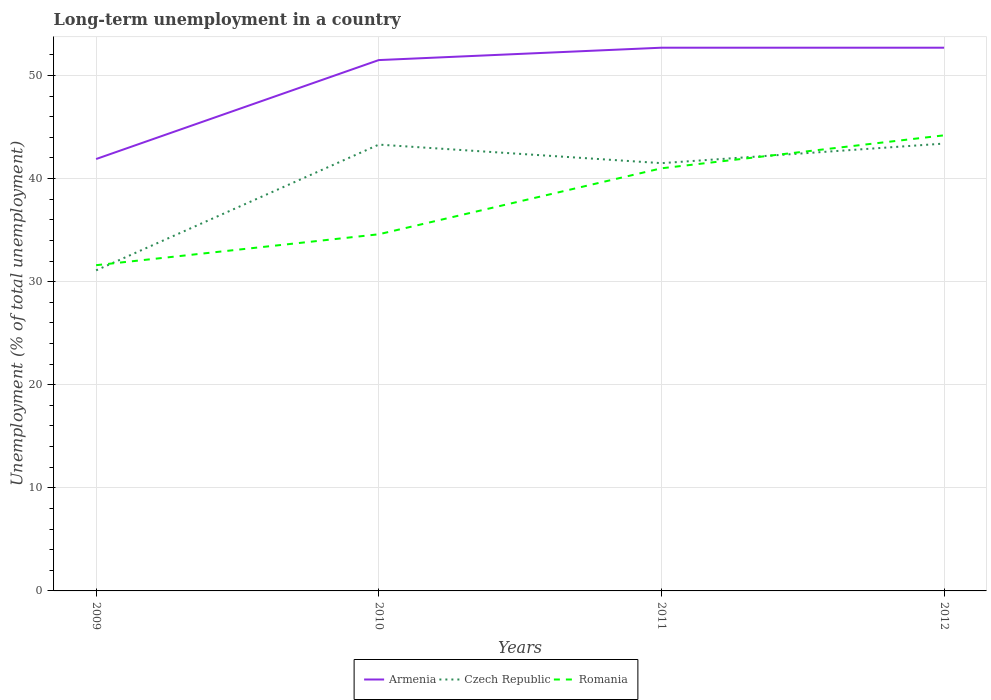How many different coloured lines are there?
Give a very brief answer. 3. Across all years, what is the maximum percentage of long-term unemployed population in Czech Republic?
Keep it short and to the point. 31.1. What is the total percentage of long-term unemployed population in Romania in the graph?
Give a very brief answer. -9.4. What is the difference between the highest and the second highest percentage of long-term unemployed population in Czech Republic?
Keep it short and to the point. 12.3. What is the difference between the highest and the lowest percentage of long-term unemployed population in Czech Republic?
Offer a terse response. 3. How many lines are there?
Give a very brief answer. 3. How many years are there in the graph?
Provide a succinct answer. 4. What is the difference between two consecutive major ticks on the Y-axis?
Your response must be concise. 10. Are the values on the major ticks of Y-axis written in scientific E-notation?
Your answer should be compact. No. Does the graph contain any zero values?
Ensure brevity in your answer.  No. Does the graph contain grids?
Offer a terse response. Yes. How many legend labels are there?
Your answer should be compact. 3. How are the legend labels stacked?
Give a very brief answer. Horizontal. What is the title of the graph?
Your answer should be very brief. Long-term unemployment in a country. What is the label or title of the X-axis?
Keep it short and to the point. Years. What is the label or title of the Y-axis?
Offer a terse response. Unemployment (% of total unemployment). What is the Unemployment (% of total unemployment) of Armenia in 2009?
Provide a succinct answer. 41.9. What is the Unemployment (% of total unemployment) in Czech Republic in 2009?
Give a very brief answer. 31.1. What is the Unemployment (% of total unemployment) in Romania in 2009?
Make the answer very short. 31.6. What is the Unemployment (% of total unemployment) in Armenia in 2010?
Offer a terse response. 51.5. What is the Unemployment (% of total unemployment) in Czech Republic in 2010?
Provide a short and direct response. 43.3. What is the Unemployment (% of total unemployment) in Romania in 2010?
Provide a succinct answer. 34.6. What is the Unemployment (% of total unemployment) of Armenia in 2011?
Keep it short and to the point. 52.7. What is the Unemployment (% of total unemployment) in Czech Republic in 2011?
Your response must be concise. 41.5. What is the Unemployment (% of total unemployment) of Armenia in 2012?
Provide a short and direct response. 52.7. What is the Unemployment (% of total unemployment) in Czech Republic in 2012?
Your answer should be compact. 43.4. What is the Unemployment (% of total unemployment) in Romania in 2012?
Ensure brevity in your answer.  44.2. Across all years, what is the maximum Unemployment (% of total unemployment) of Armenia?
Your answer should be compact. 52.7. Across all years, what is the maximum Unemployment (% of total unemployment) of Czech Republic?
Ensure brevity in your answer.  43.4. Across all years, what is the maximum Unemployment (% of total unemployment) in Romania?
Provide a short and direct response. 44.2. Across all years, what is the minimum Unemployment (% of total unemployment) in Armenia?
Your answer should be compact. 41.9. Across all years, what is the minimum Unemployment (% of total unemployment) of Czech Republic?
Provide a short and direct response. 31.1. Across all years, what is the minimum Unemployment (% of total unemployment) of Romania?
Keep it short and to the point. 31.6. What is the total Unemployment (% of total unemployment) in Armenia in the graph?
Keep it short and to the point. 198.8. What is the total Unemployment (% of total unemployment) of Czech Republic in the graph?
Give a very brief answer. 159.3. What is the total Unemployment (% of total unemployment) of Romania in the graph?
Offer a very short reply. 151.4. What is the difference between the Unemployment (% of total unemployment) of Armenia in 2009 and that in 2010?
Provide a succinct answer. -9.6. What is the difference between the Unemployment (% of total unemployment) of Romania in 2009 and that in 2010?
Make the answer very short. -3. What is the difference between the Unemployment (% of total unemployment) of Armenia in 2009 and that in 2011?
Make the answer very short. -10.8. What is the difference between the Unemployment (% of total unemployment) of Czech Republic in 2009 and that in 2011?
Give a very brief answer. -10.4. What is the difference between the Unemployment (% of total unemployment) of Armenia in 2009 and that in 2012?
Make the answer very short. -10.8. What is the difference between the Unemployment (% of total unemployment) of Romania in 2009 and that in 2012?
Provide a short and direct response. -12.6. What is the difference between the Unemployment (% of total unemployment) in Armenia in 2010 and that in 2011?
Offer a terse response. -1.2. What is the difference between the Unemployment (% of total unemployment) in Romania in 2010 and that in 2011?
Provide a short and direct response. -6.4. What is the difference between the Unemployment (% of total unemployment) in Armenia in 2010 and that in 2012?
Make the answer very short. -1.2. What is the difference between the Unemployment (% of total unemployment) in Czech Republic in 2011 and that in 2012?
Keep it short and to the point. -1.9. What is the difference between the Unemployment (% of total unemployment) in Romania in 2011 and that in 2012?
Give a very brief answer. -3.2. What is the difference between the Unemployment (% of total unemployment) in Czech Republic in 2009 and the Unemployment (% of total unemployment) in Romania in 2010?
Offer a very short reply. -3.5. What is the difference between the Unemployment (% of total unemployment) of Armenia in 2009 and the Unemployment (% of total unemployment) of Czech Republic in 2011?
Provide a succinct answer. 0.4. What is the difference between the Unemployment (% of total unemployment) of Armenia in 2009 and the Unemployment (% of total unemployment) of Romania in 2011?
Ensure brevity in your answer.  0.9. What is the difference between the Unemployment (% of total unemployment) in Czech Republic in 2009 and the Unemployment (% of total unemployment) in Romania in 2011?
Ensure brevity in your answer.  -9.9. What is the difference between the Unemployment (% of total unemployment) of Armenia in 2009 and the Unemployment (% of total unemployment) of Romania in 2012?
Your answer should be very brief. -2.3. What is the difference between the Unemployment (% of total unemployment) in Czech Republic in 2009 and the Unemployment (% of total unemployment) in Romania in 2012?
Offer a terse response. -13.1. What is the difference between the Unemployment (% of total unemployment) of Armenia in 2010 and the Unemployment (% of total unemployment) of Romania in 2011?
Offer a terse response. 10.5. What is the difference between the Unemployment (% of total unemployment) in Czech Republic in 2010 and the Unemployment (% of total unemployment) in Romania in 2011?
Your response must be concise. 2.3. What is the difference between the Unemployment (% of total unemployment) in Armenia in 2010 and the Unemployment (% of total unemployment) in Czech Republic in 2012?
Your response must be concise. 8.1. What is the difference between the Unemployment (% of total unemployment) in Armenia in 2011 and the Unemployment (% of total unemployment) in Czech Republic in 2012?
Offer a very short reply. 9.3. What is the difference between the Unemployment (% of total unemployment) in Armenia in 2011 and the Unemployment (% of total unemployment) in Romania in 2012?
Offer a very short reply. 8.5. What is the difference between the Unemployment (% of total unemployment) in Czech Republic in 2011 and the Unemployment (% of total unemployment) in Romania in 2012?
Keep it short and to the point. -2.7. What is the average Unemployment (% of total unemployment) of Armenia per year?
Make the answer very short. 49.7. What is the average Unemployment (% of total unemployment) of Czech Republic per year?
Keep it short and to the point. 39.83. What is the average Unemployment (% of total unemployment) of Romania per year?
Make the answer very short. 37.85. In the year 2010, what is the difference between the Unemployment (% of total unemployment) in Armenia and Unemployment (% of total unemployment) in Romania?
Make the answer very short. 16.9. In the year 2010, what is the difference between the Unemployment (% of total unemployment) of Czech Republic and Unemployment (% of total unemployment) of Romania?
Your response must be concise. 8.7. In the year 2011, what is the difference between the Unemployment (% of total unemployment) of Armenia and Unemployment (% of total unemployment) of Czech Republic?
Provide a succinct answer. 11.2. In the year 2011, what is the difference between the Unemployment (% of total unemployment) in Armenia and Unemployment (% of total unemployment) in Romania?
Your answer should be compact. 11.7. What is the ratio of the Unemployment (% of total unemployment) in Armenia in 2009 to that in 2010?
Keep it short and to the point. 0.81. What is the ratio of the Unemployment (% of total unemployment) of Czech Republic in 2009 to that in 2010?
Ensure brevity in your answer.  0.72. What is the ratio of the Unemployment (% of total unemployment) of Romania in 2009 to that in 2010?
Provide a short and direct response. 0.91. What is the ratio of the Unemployment (% of total unemployment) in Armenia in 2009 to that in 2011?
Make the answer very short. 0.8. What is the ratio of the Unemployment (% of total unemployment) of Czech Republic in 2009 to that in 2011?
Your answer should be compact. 0.75. What is the ratio of the Unemployment (% of total unemployment) of Romania in 2009 to that in 2011?
Your response must be concise. 0.77. What is the ratio of the Unemployment (% of total unemployment) of Armenia in 2009 to that in 2012?
Make the answer very short. 0.8. What is the ratio of the Unemployment (% of total unemployment) in Czech Republic in 2009 to that in 2012?
Ensure brevity in your answer.  0.72. What is the ratio of the Unemployment (% of total unemployment) in Romania in 2009 to that in 2012?
Keep it short and to the point. 0.71. What is the ratio of the Unemployment (% of total unemployment) of Armenia in 2010 to that in 2011?
Offer a terse response. 0.98. What is the ratio of the Unemployment (% of total unemployment) in Czech Republic in 2010 to that in 2011?
Your answer should be compact. 1.04. What is the ratio of the Unemployment (% of total unemployment) of Romania in 2010 to that in 2011?
Your answer should be compact. 0.84. What is the ratio of the Unemployment (% of total unemployment) in Armenia in 2010 to that in 2012?
Provide a succinct answer. 0.98. What is the ratio of the Unemployment (% of total unemployment) of Romania in 2010 to that in 2012?
Give a very brief answer. 0.78. What is the ratio of the Unemployment (% of total unemployment) of Armenia in 2011 to that in 2012?
Your answer should be very brief. 1. What is the ratio of the Unemployment (% of total unemployment) in Czech Republic in 2011 to that in 2012?
Offer a very short reply. 0.96. What is the ratio of the Unemployment (% of total unemployment) in Romania in 2011 to that in 2012?
Give a very brief answer. 0.93. What is the difference between the highest and the lowest Unemployment (% of total unemployment) of Czech Republic?
Your answer should be compact. 12.3. 